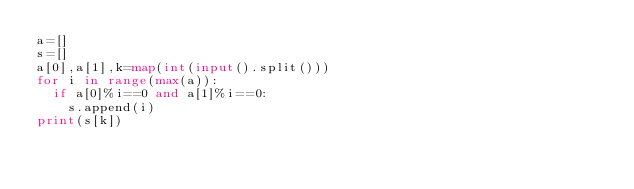<code> <loc_0><loc_0><loc_500><loc_500><_Python_>a=[]
s=[]
a[0],a[1],k=map(int(input().split()))
for i in range(max(a)):
  if a[0]%i==0 and a[1]%i==0:
    s.append(i)
print(s[k])</code> 